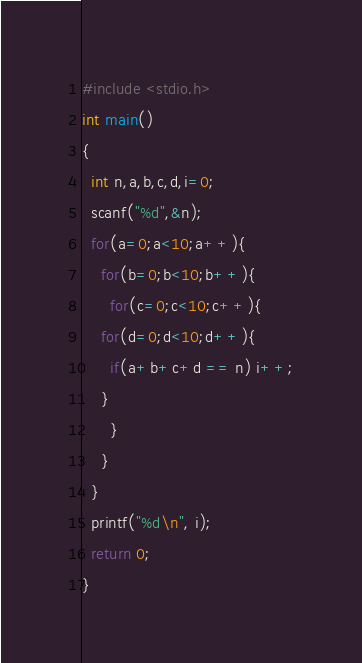Convert code to text. <code><loc_0><loc_0><loc_500><loc_500><_C_>#include <stdio.h>
int main()
{
  int n,a,b,c,d,i=0;
  scanf("%d",&n);
  for(a=0;a<10;a++){
    for(b=0;b<10;b++){
      for(c=0;c<10;c++){
	for(d=0;d<10;d++){
	  if(a+b+c+d == n) i++;
	}
      }
    }
  }
  printf("%d\n", i);
  return 0;
}</code> 